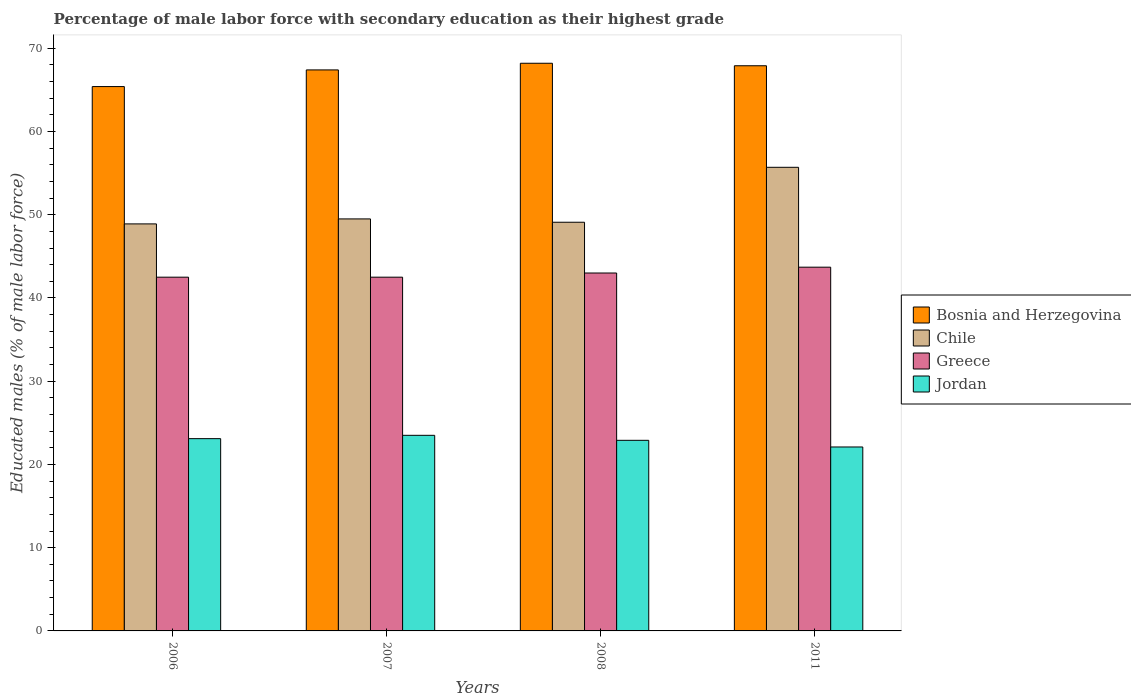How many different coloured bars are there?
Provide a short and direct response. 4. How many groups of bars are there?
Offer a terse response. 4. What is the label of the 1st group of bars from the left?
Make the answer very short. 2006. In how many cases, is the number of bars for a given year not equal to the number of legend labels?
Your response must be concise. 0. What is the percentage of male labor force with secondary education in Chile in 2008?
Make the answer very short. 49.1. Across all years, what is the maximum percentage of male labor force with secondary education in Bosnia and Herzegovina?
Provide a succinct answer. 68.2. Across all years, what is the minimum percentage of male labor force with secondary education in Jordan?
Your answer should be compact. 22.1. In which year was the percentage of male labor force with secondary education in Jordan maximum?
Your response must be concise. 2007. What is the total percentage of male labor force with secondary education in Jordan in the graph?
Offer a terse response. 91.6. What is the difference between the percentage of male labor force with secondary education in Jordan in 2008 and that in 2011?
Give a very brief answer. 0.8. What is the difference between the percentage of male labor force with secondary education in Greece in 2008 and the percentage of male labor force with secondary education in Bosnia and Herzegovina in 2006?
Ensure brevity in your answer.  -22.4. What is the average percentage of male labor force with secondary education in Jordan per year?
Provide a succinct answer. 22.9. In the year 2006, what is the difference between the percentage of male labor force with secondary education in Chile and percentage of male labor force with secondary education in Jordan?
Offer a very short reply. 25.8. What is the ratio of the percentage of male labor force with secondary education in Jordan in 2008 to that in 2011?
Provide a short and direct response. 1.04. What is the difference between the highest and the second highest percentage of male labor force with secondary education in Bosnia and Herzegovina?
Offer a very short reply. 0.3. What is the difference between the highest and the lowest percentage of male labor force with secondary education in Jordan?
Your response must be concise. 1.4. In how many years, is the percentage of male labor force with secondary education in Bosnia and Herzegovina greater than the average percentage of male labor force with secondary education in Bosnia and Herzegovina taken over all years?
Ensure brevity in your answer.  3. Is the sum of the percentage of male labor force with secondary education in Chile in 2007 and 2008 greater than the maximum percentage of male labor force with secondary education in Jordan across all years?
Offer a very short reply. Yes. What does the 4th bar from the left in 2008 represents?
Your answer should be very brief. Jordan. What does the 2nd bar from the right in 2011 represents?
Your answer should be compact. Greece. How many bars are there?
Make the answer very short. 16. Does the graph contain any zero values?
Your answer should be compact. No. Where does the legend appear in the graph?
Your response must be concise. Center right. How are the legend labels stacked?
Offer a very short reply. Vertical. What is the title of the graph?
Your answer should be compact. Percentage of male labor force with secondary education as their highest grade. Does "Egypt, Arab Rep." appear as one of the legend labels in the graph?
Give a very brief answer. No. What is the label or title of the Y-axis?
Your response must be concise. Educated males (% of male labor force). What is the Educated males (% of male labor force) in Bosnia and Herzegovina in 2006?
Your answer should be very brief. 65.4. What is the Educated males (% of male labor force) in Chile in 2006?
Provide a short and direct response. 48.9. What is the Educated males (% of male labor force) in Greece in 2006?
Your response must be concise. 42.5. What is the Educated males (% of male labor force) in Jordan in 2006?
Keep it short and to the point. 23.1. What is the Educated males (% of male labor force) of Bosnia and Herzegovina in 2007?
Make the answer very short. 67.4. What is the Educated males (% of male labor force) in Chile in 2007?
Ensure brevity in your answer.  49.5. What is the Educated males (% of male labor force) of Greece in 2007?
Give a very brief answer. 42.5. What is the Educated males (% of male labor force) in Jordan in 2007?
Your response must be concise. 23.5. What is the Educated males (% of male labor force) in Bosnia and Herzegovina in 2008?
Give a very brief answer. 68.2. What is the Educated males (% of male labor force) of Chile in 2008?
Keep it short and to the point. 49.1. What is the Educated males (% of male labor force) in Jordan in 2008?
Your answer should be very brief. 22.9. What is the Educated males (% of male labor force) of Bosnia and Herzegovina in 2011?
Ensure brevity in your answer.  67.9. What is the Educated males (% of male labor force) of Chile in 2011?
Your response must be concise. 55.7. What is the Educated males (% of male labor force) in Greece in 2011?
Offer a terse response. 43.7. What is the Educated males (% of male labor force) in Jordan in 2011?
Your answer should be compact. 22.1. Across all years, what is the maximum Educated males (% of male labor force) of Bosnia and Herzegovina?
Provide a short and direct response. 68.2. Across all years, what is the maximum Educated males (% of male labor force) in Chile?
Your answer should be very brief. 55.7. Across all years, what is the maximum Educated males (% of male labor force) of Greece?
Your answer should be very brief. 43.7. Across all years, what is the maximum Educated males (% of male labor force) in Jordan?
Offer a terse response. 23.5. Across all years, what is the minimum Educated males (% of male labor force) in Bosnia and Herzegovina?
Keep it short and to the point. 65.4. Across all years, what is the minimum Educated males (% of male labor force) of Chile?
Your response must be concise. 48.9. Across all years, what is the minimum Educated males (% of male labor force) in Greece?
Make the answer very short. 42.5. Across all years, what is the minimum Educated males (% of male labor force) in Jordan?
Keep it short and to the point. 22.1. What is the total Educated males (% of male labor force) in Bosnia and Herzegovina in the graph?
Give a very brief answer. 268.9. What is the total Educated males (% of male labor force) of Chile in the graph?
Your answer should be compact. 203.2. What is the total Educated males (% of male labor force) in Greece in the graph?
Offer a terse response. 171.7. What is the total Educated males (% of male labor force) of Jordan in the graph?
Keep it short and to the point. 91.6. What is the difference between the Educated males (% of male labor force) of Greece in 2006 and that in 2007?
Make the answer very short. 0. What is the difference between the Educated males (% of male labor force) in Jordan in 2006 and that in 2007?
Keep it short and to the point. -0.4. What is the difference between the Educated males (% of male labor force) in Greece in 2006 and that in 2008?
Your response must be concise. -0.5. What is the difference between the Educated males (% of male labor force) in Greece in 2006 and that in 2011?
Your answer should be compact. -1.2. What is the difference between the Educated males (% of male labor force) in Chile in 2007 and that in 2008?
Your answer should be compact. 0.4. What is the difference between the Educated males (% of male labor force) in Jordan in 2007 and that in 2008?
Your answer should be compact. 0.6. What is the difference between the Educated males (% of male labor force) of Jordan in 2007 and that in 2011?
Keep it short and to the point. 1.4. What is the difference between the Educated males (% of male labor force) of Chile in 2008 and that in 2011?
Make the answer very short. -6.6. What is the difference between the Educated males (% of male labor force) of Jordan in 2008 and that in 2011?
Ensure brevity in your answer.  0.8. What is the difference between the Educated males (% of male labor force) of Bosnia and Herzegovina in 2006 and the Educated males (% of male labor force) of Greece in 2007?
Provide a short and direct response. 22.9. What is the difference between the Educated males (% of male labor force) in Bosnia and Herzegovina in 2006 and the Educated males (% of male labor force) in Jordan in 2007?
Offer a very short reply. 41.9. What is the difference between the Educated males (% of male labor force) of Chile in 2006 and the Educated males (% of male labor force) of Jordan in 2007?
Offer a terse response. 25.4. What is the difference between the Educated males (% of male labor force) of Bosnia and Herzegovina in 2006 and the Educated males (% of male labor force) of Chile in 2008?
Your response must be concise. 16.3. What is the difference between the Educated males (% of male labor force) in Bosnia and Herzegovina in 2006 and the Educated males (% of male labor force) in Greece in 2008?
Ensure brevity in your answer.  22.4. What is the difference between the Educated males (% of male labor force) of Bosnia and Herzegovina in 2006 and the Educated males (% of male labor force) of Jordan in 2008?
Provide a succinct answer. 42.5. What is the difference between the Educated males (% of male labor force) in Chile in 2006 and the Educated males (% of male labor force) in Jordan in 2008?
Keep it short and to the point. 26. What is the difference between the Educated males (% of male labor force) of Greece in 2006 and the Educated males (% of male labor force) of Jordan in 2008?
Your answer should be compact. 19.6. What is the difference between the Educated males (% of male labor force) in Bosnia and Herzegovina in 2006 and the Educated males (% of male labor force) in Chile in 2011?
Provide a short and direct response. 9.7. What is the difference between the Educated males (% of male labor force) of Bosnia and Herzegovina in 2006 and the Educated males (% of male labor force) of Greece in 2011?
Your response must be concise. 21.7. What is the difference between the Educated males (% of male labor force) in Bosnia and Herzegovina in 2006 and the Educated males (% of male labor force) in Jordan in 2011?
Provide a succinct answer. 43.3. What is the difference between the Educated males (% of male labor force) in Chile in 2006 and the Educated males (% of male labor force) in Jordan in 2011?
Your answer should be very brief. 26.8. What is the difference between the Educated males (% of male labor force) in Greece in 2006 and the Educated males (% of male labor force) in Jordan in 2011?
Offer a very short reply. 20.4. What is the difference between the Educated males (% of male labor force) of Bosnia and Herzegovina in 2007 and the Educated males (% of male labor force) of Chile in 2008?
Ensure brevity in your answer.  18.3. What is the difference between the Educated males (% of male labor force) of Bosnia and Herzegovina in 2007 and the Educated males (% of male labor force) of Greece in 2008?
Offer a very short reply. 24.4. What is the difference between the Educated males (% of male labor force) in Bosnia and Herzegovina in 2007 and the Educated males (% of male labor force) in Jordan in 2008?
Offer a very short reply. 44.5. What is the difference between the Educated males (% of male labor force) of Chile in 2007 and the Educated males (% of male labor force) of Jordan in 2008?
Your answer should be very brief. 26.6. What is the difference between the Educated males (% of male labor force) in Greece in 2007 and the Educated males (% of male labor force) in Jordan in 2008?
Your response must be concise. 19.6. What is the difference between the Educated males (% of male labor force) of Bosnia and Herzegovina in 2007 and the Educated males (% of male labor force) of Chile in 2011?
Ensure brevity in your answer.  11.7. What is the difference between the Educated males (% of male labor force) in Bosnia and Herzegovina in 2007 and the Educated males (% of male labor force) in Greece in 2011?
Ensure brevity in your answer.  23.7. What is the difference between the Educated males (% of male labor force) of Bosnia and Herzegovina in 2007 and the Educated males (% of male labor force) of Jordan in 2011?
Make the answer very short. 45.3. What is the difference between the Educated males (% of male labor force) in Chile in 2007 and the Educated males (% of male labor force) in Greece in 2011?
Offer a terse response. 5.8. What is the difference between the Educated males (% of male labor force) of Chile in 2007 and the Educated males (% of male labor force) of Jordan in 2011?
Keep it short and to the point. 27.4. What is the difference between the Educated males (% of male labor force) of Greece in 2007 and the Educated males (% of male labor force) of Jordan in 2011?
Provide a succinct answer. 20.4. What is the difference between the Educated males (% of male labor force) of Bosnia and Herzegovina in 2008 and the Educated males (% of male labor force) of Greece in 2011?
Your answer should be very brief. 24.5. What is the difference between the Educated males (% of male labor force) of Bosnia and Herzegovina in 2008 and the Educated males (% of male labor force) of Jordan in 2011?
Ensure brevity in your answer.  46.1. What is the difference between the Educated males (% of male labor force) of Greece in 2008 and the Educated males (% of male labor force) of Jordan in 2011?
Offer a very short reply. 20.9. What is the average Educated males (% of male labor force) in Bosnia and Herzegovina per year?
Your answer should be very brief. 67.22. What is the average Educated males (% of male labor force) in Chile per year?
Your response must be concise. 50.8. What is the average Educated males (% of male labor force) of Greece per year?
Ensure brevity in your answer.  42.92. What is the average Educated males (% of male labor force) of Jordan per year?
Give a very brief answer. 22.9. In the year 2006, what is the difference between the Educated males (% of male labor force) in Bosnia and Herzegovina and Educated males (% of male labor force) in Greece?
Your answer should be very brief. 22.9. In the year 2006, what is the difference between the Educated males (% of male labor force) in Bosnia and Herzegovina and Educated males (% of male labor force) in Jordan?
Your response must be concise. 42.3. In the year 2006, what is the difference between the Educated males (% of male labor force) in Chile and Educated males (% of male labor force) in Jordan?
Offer a terse response. 25.8. In the year 2006, what is the difference between the Educated males (% of male labor force) of Greece and Educated males (% of male labor force) of Jordan?
Your answer should be very brief. 19.4. In the year 2007, what is the difference between the Educated males (% of male labor force) of Bosnia and Herzegovina and Educated males (% of male labor force) of Greece?
Offer a terse response. 24.9. In the year 2007, what is the difference between the Educated males (% of male labor force) in Bosnia and Herzegovina and Educated males (% of male labor force) in Jordan?
Ensure brevity in your answer.  43.9. In the year 2007, what is the difference between the Educated males (% of male labor force) in Chile and Educated males (% of male labor force) in Greece?
Make the answer very short. 7. In the year 2007, what is the difference between the Educated males (% of male labor force) in Chile and Educated males (% of male labor force) in Jordan?
Give a very brief answer. 26. In the year 2008, what is the difference between the Educated males (% of male labor force) of Bosnia and Herzegovina and Educated males (% of male labor force) of Greece?
Give a very brief answer. 25.2. In the year 2008, what is the difference between the Educated males (% of male labor force) of Bosnia and Herzegovina and Educated males (% of male labor force) of Jordan?
Ensure brevity in your answer.  45.3. In the year 2008, what is the difference between the Educated males (% of male labor force) of Chile and Educated males (% of male labor force) of Jordan?
Ensure brevity in your answer.  26.2. In the year 2008, what is the difference between the Educated males (% of male labor force) in Greece and Educated males (% of male labor force) in Jordan?
Provide a succinct answer. 20.1. In the year 2011, what is the difference between the Educated males (% of male labor force) of Bosnia and Herzegovina and Educated males (% of male labor force) of Greece?
Give a very brief answer. 24.2. In the year 2011, what is the difference between the Educated males (% of male labor force) in Bosnia and Herzegovina and Educated males (% of male labor force) in Jordan?
Keep it short and to the point. 45.8. In the year 2011, what is the difference between the Educated males (% of male labor force) in Chile and Educated males (% of male labor force) in Greece?
Offer a terse response. 12. In the year 2011, what is the difference between the Educated males (% of male labor force) in Chile and Educated males (% of male labor force) in Jordan?
Provide a succinct answer. 33.6. In the year 2011, what is the difference between the Educated males (% of male labor force) of Greece and Educated males (% of male labor force) of Jordan?
Your answer should be compact. 21.6. What is the ratio of the Educated males (% of male labor force) of Bosnia and Herzegovina in 2006 to that in 2007?
Your answer should be very brief. 0.97. What is the ratio of the Educated males (% of male labor force) of Chile in 2006 to that in 2007?
Ensure brevity in your answer.  0.99. What is the ratio of the Educated males (% of male labor force) of Greece in 2006 to that in 2007?
Your answer should be very brief. 1. What is the ratio of the Educated males (% of male labor force) of Jordan in 2006 to that in 2007?
Ensure brevity in your answer.  0.98. What is the ratio of the Educated males (% of male labor force) in Bosnia and Herzegovina in 2006 to that in 2008?
Offer a terse response. 0.96. What is the ratio of the Educated males (% of male labor force) in Chile in 2006 to that in 2008?
Offer a very short reply. 1. What is the ratio of the Educated males (% of male labor force) of Greece in 2006 to that in 2008?
Your answer should be compact. 0.99. What is the ratio of the Educated males (% of male labor force) in Jordan in 2006 to that in 2008?
Offer a terse response. 1.01. What is the ratio of the Educated males (% of male labor force) in Bosnia and Herzegovina in 2006 to that in 2011?
Give a very brief answer. 0.96. What is the ratio of the Educated males (% of male labor force) of Chile in 2006 to that in 2011?
Keep it short and to the point. 0.88. What is the ratio of the Educated males (% of male labor force) of Greece in 2006 to that in 2011?
Provide a succinct answer. 0.97. What is the ratio of the Educated males (% of male labor force) in Jordan in 2006 to that in 2011?
Give a very brief answer. 1.05. What is the ratio of the Educated males (% of male labor force) of Bosnia and Herzegovina in 2007 to that in 2008?
Keep it short and to the point. 0.99. What is the ratio of the Educated males (% of male labor force) of Chile in 2007 to that in 2008?
Your response must be concise. 1.01. What is the ratio of the Educated males (% of male labor force) in Greece in 2007 to that in 2008?
Provide a short and direct response. 0.99. What is the ratio of the Educated males (% of male labor force) in Jordan in 2007 to that in 2008?
Your answer should be very brief. 1.03. What is the ratio of the Educated males (% of male labor force) in Chile in 2007 to that in 2011?
Keep it short and to the point. 0.89. What is the ratio of the Educated males (% of male labor force) in Greece in 2007 to that in 2011?
Offer a very short reply. 0.97. What is the ratio of the Educated males (% of male labor force) in Jordan in 2007 to that in 2011?
Provide a succinct answer. 1.06. What is the ratio of the Educated males (% of male labor force) of Chile in 2008 to that in 2011?
Give a very brief answer. 0.88. What is the ratio of the Educated males (% of male labor force) of Greece in 2008 to that in 2011?
Provide a short and direct response. 0.98. What is the ratio of the Educated males (% of male labor force) in Jordan in 2008 to that in 2011?
Provide a succinct answer. 1.04. What is the difference between the highest and the second highest Educated males (% of male labor force) of Bosnia and Herzegovina?
Your response must be concise. 0.3. What is the difference between the highest and the second highest Educated males (% of male labor force) in Chile?
Offer a very short reply. 6.2. What is the difference between the highest and the second highest Educated males (% of male labor force) of Greece?
Make the answer very short. 0.7. What is the difference between the highest and the second highest Educated males (% of male labor force) of Jordan?
Offer a very short reply. 0.4. What is the difference between the highest and the lowest Educated males (% of male labor force) in Bosnia and Herzegovina?
Make the answer very short. 2.8. What is the difference between the highest and the lowest Educated males (% of male labor force) in Greece?
Your answer should be very brief. 1.2. What is the difference between the highest and the lowest Educated males (% of male labor force) of Jordan?
Your answer should be compact. 1.4. 